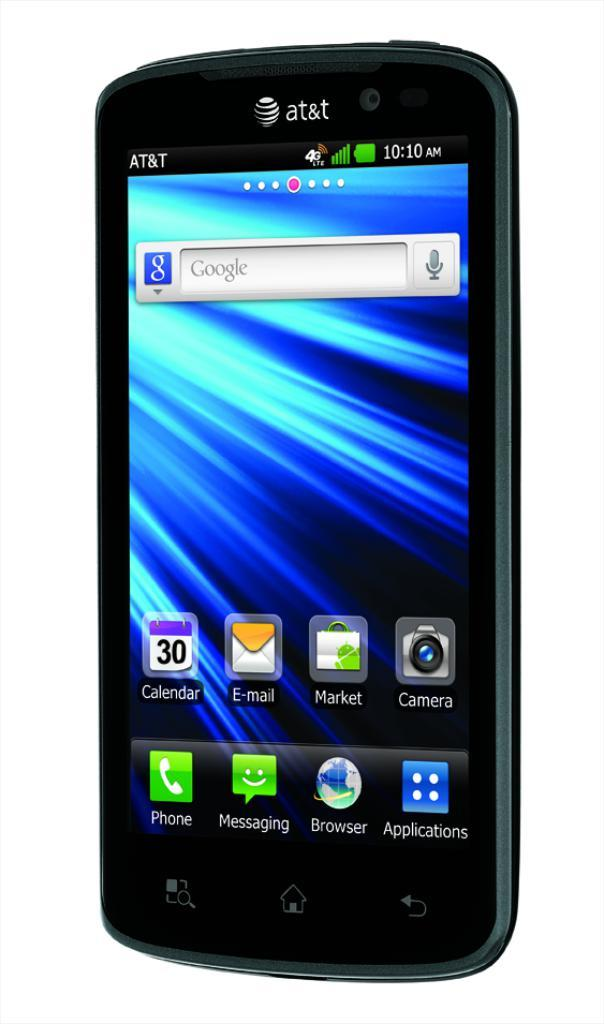Provide a one-sentence caption for the provided image. An AT&T smartphone with the calendar icon on it. 